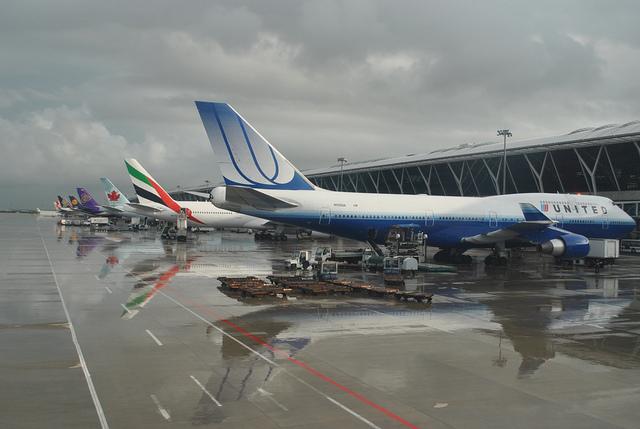Is this an international airport?
Be succinct. Yes. What is the red marking on the third airplane's tail fin?
Quick response, please. Maple leaf. Do these airplanes belong to the same airline?
Answer briefly. No. Are all the planes from the same airline?
Quick response, please. No. Are all these airplanes the same size?
Give a very brief answer. Yes. How many people are in this image?
Write a very short answer. 0. 